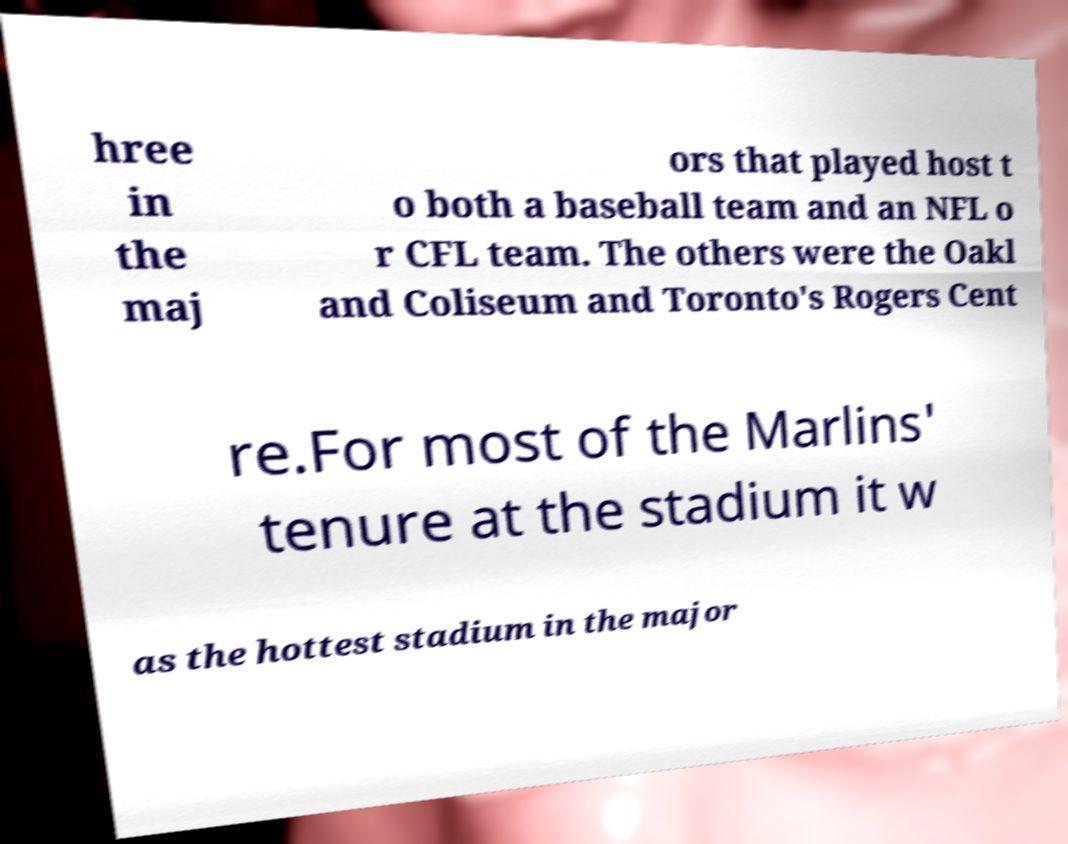I need the written content from this picture converted into text. Can you do that? hree in the maj ors that played host t o both a baseball team and an NFL o r CFL team. The others were the Oakl and Coliseum and Toronto's Rogers Cent re.For most of the Marlins' tenure at the stadium it w as the hottest stadium in the major 